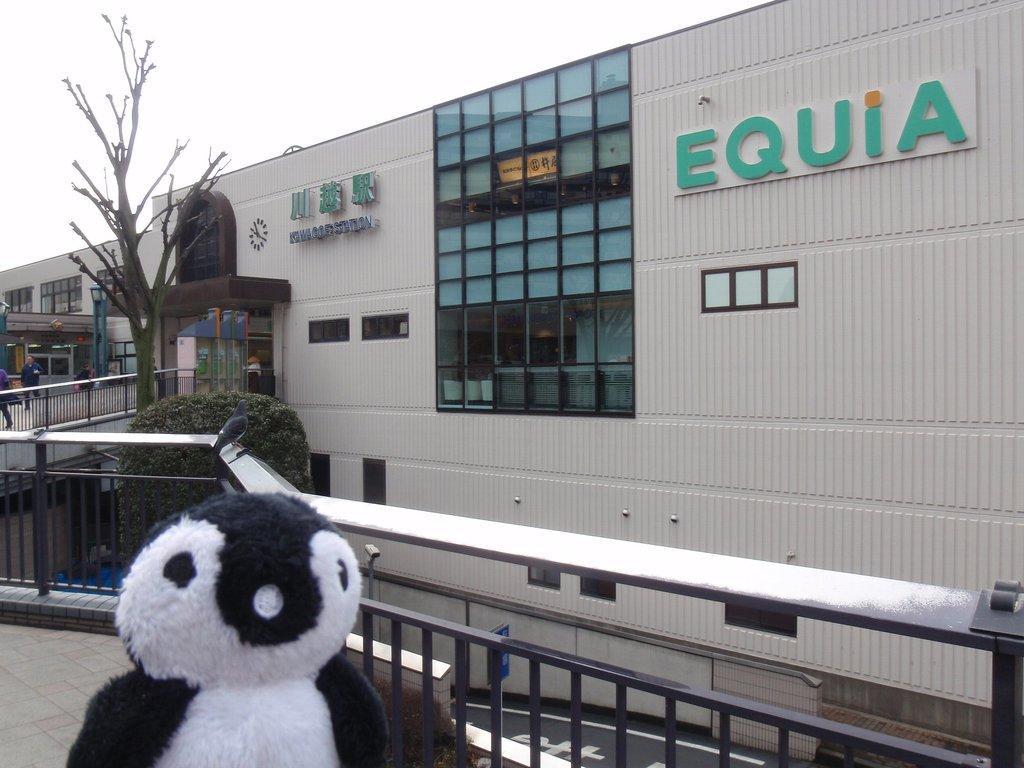In one or two sentences, can you explain what this image depicts? In this image there is a stuffed toy on the bridge. In the background there is a building with the glass windows. At the top there is the sky. There is a tree behind the toy. At the bottom there is a road. On the left side there are few people walking on the bridge. There is a fence around the bridge. 